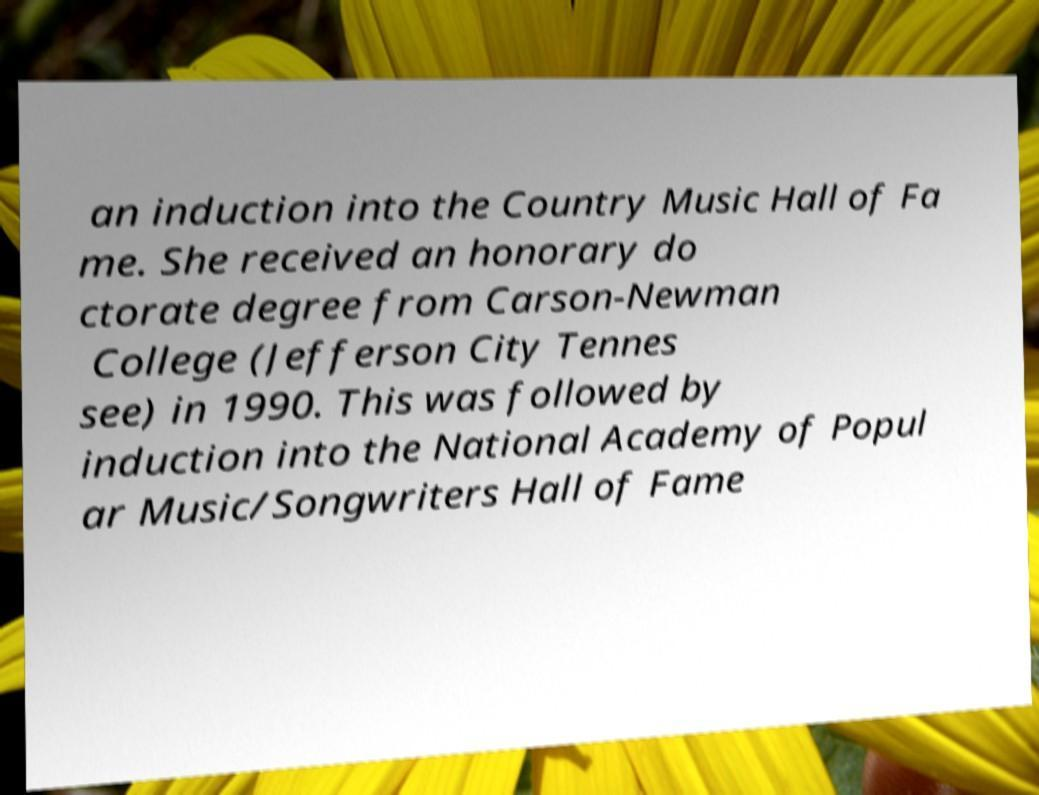Can you accurately transcribe the text from the provided image for me? an induction into the Country Music Hall of Fa me. She received an honorary do ctorate degree from Carson-Newman College (Jefferson City Tennes see) in 1990. This was followed by induction into the National Academy of Popul ar Music/Songwriters Hall of Fame 